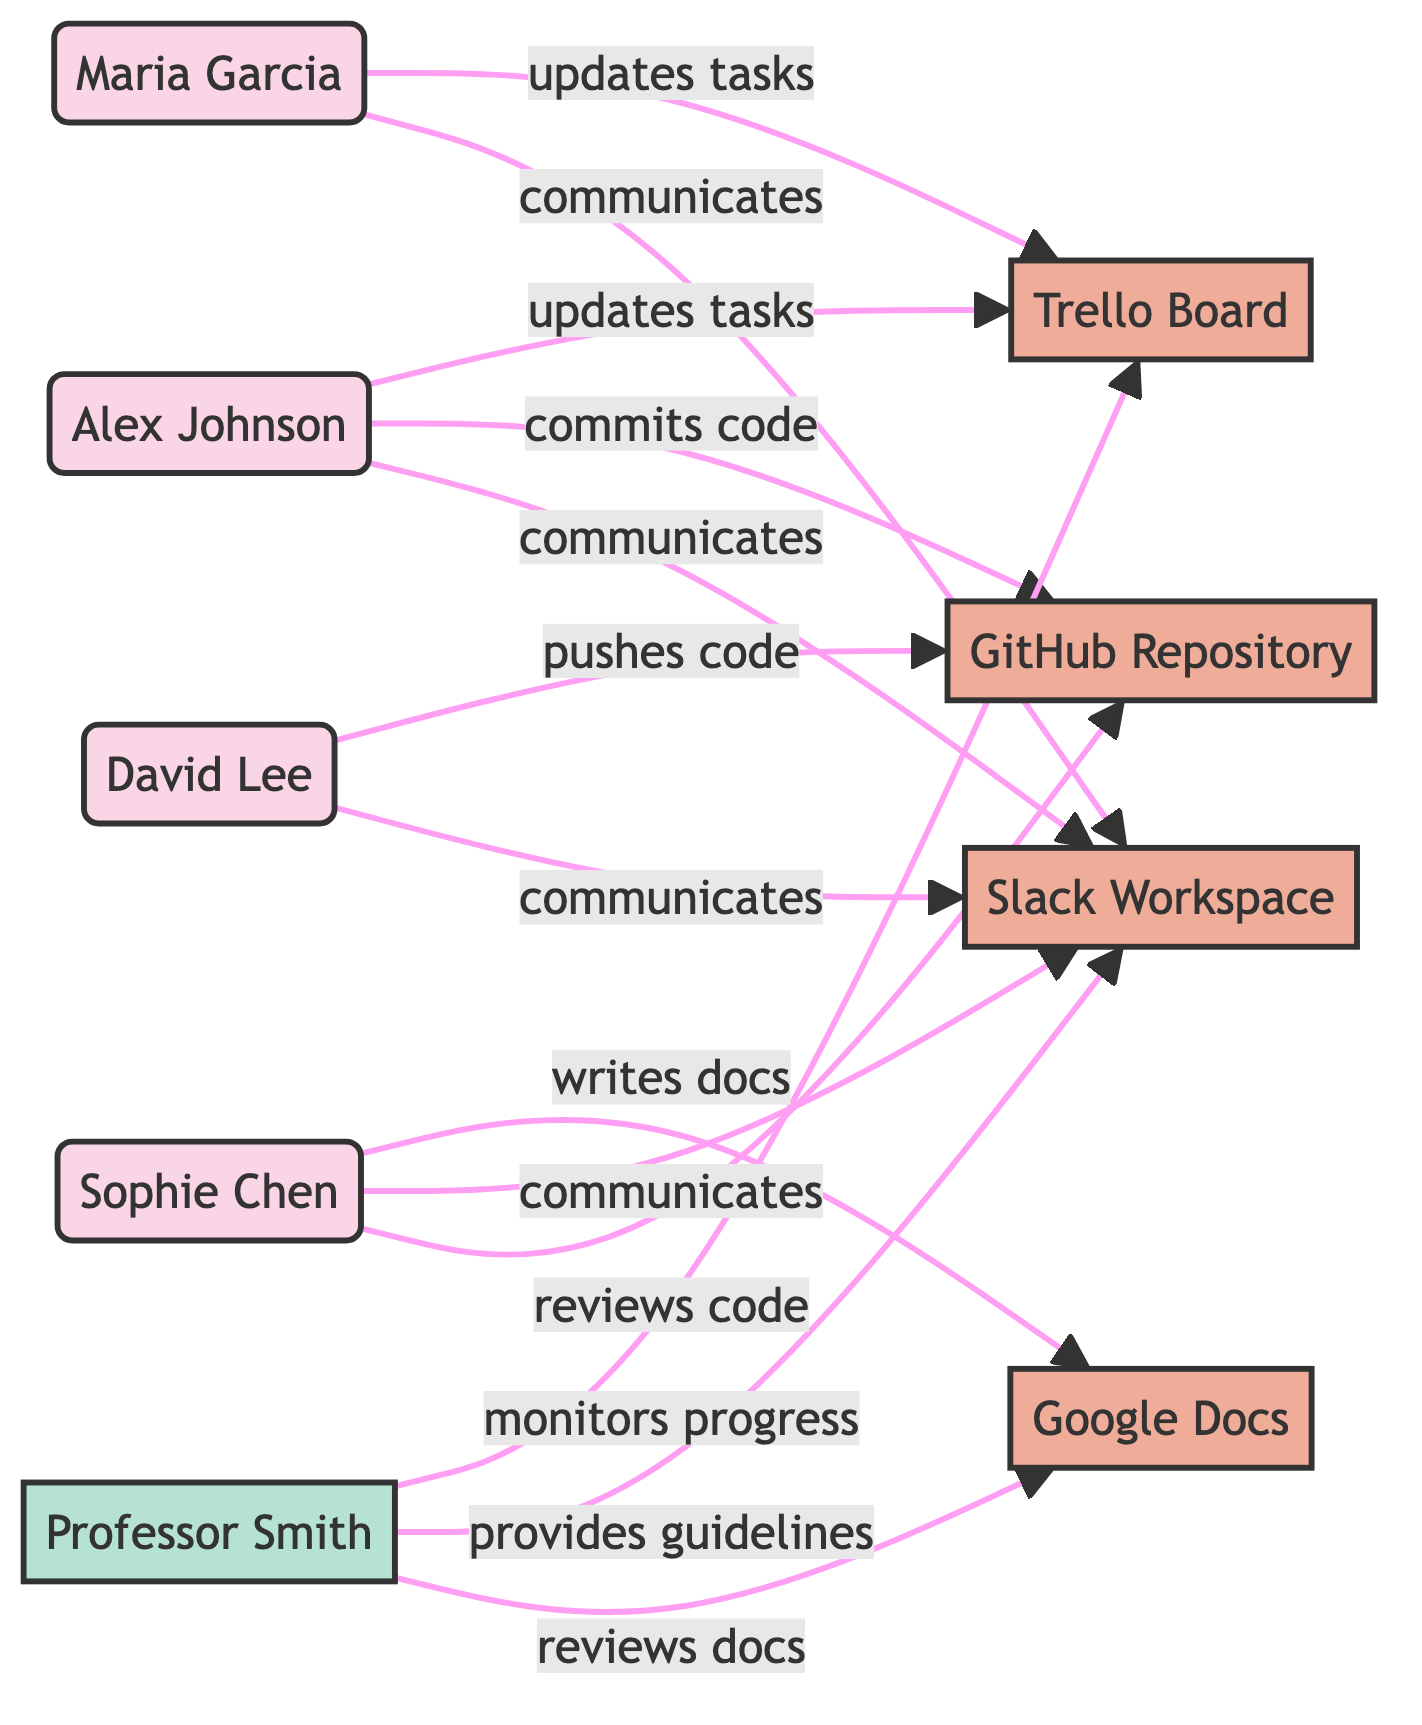What are the names of the students in the diagram? The diagram features four students: Alex Johnson, Maria Garcia, David Lee, and Sophie Chen, as represented by their corresponding nodes.
Answer: Alex Johnson, Maria Garcia, David Lee, Sophie Chen How many tools are represented in the diagram? There are four tools in the diagram: Trello Board, GitHub Repository, Slack Workspace, and Google Docs as seen in the node specifications.
Answer: 4 Who communicates with the Slack Workspace? The edges show that all four students (Alex Johnson, Maria Garcia, David Lee, and Sophie Chen) communicate with the Slack Workspace, which connects to each of them based on the labeled relationships.
Answer: Alex Johnson, Maria Garcia, David Lee, Sophie Chen Which student pushes code to the GitHub Repository? According to the diagram, David Lee and Alex Johnson are connected to the GitHub Repository with actions clearly stating "pushes code" and "commits code", respectively. Thus, David Lee is identified as the one who pushes code.
Answer: David Lee What action does Professor Smith perform related to the documentation tool? The edge indicates that Professor Smith reviews the Google Docs documentation tool, which is denoted with the label "reviews docs" pointing from professor to documentation_tool.
Answer: reviews docs How many edges are there in the diagram? The total number of edges can be determined by counting each connection in the diagram which shows interactions or relationships; there are 13 edges in this network diagram.
Answer: 13 Which student reviews code in the GitHub Repository? The diagram specifies that Sophie Chen has the relationship labeled "reviews code" connecting her to the GitHub Repository, indicating her involvement in this action.
Answer: Sophie Chen What is the purpose of the Trello Board in the diagram? The diagram outlines that the Trello Board serves as a project management tool where Alex Johnson and Maria Garcia update tasks, indicating its role for coordinating project efforts.
Answer: updates tasks Who monitors progress in the project management tool? The edge labeled "monitors progress" directed towards the Trello Board shows that Professor Smith is the individual responsible for this action within the diagram.
Answer: Professor Smith 